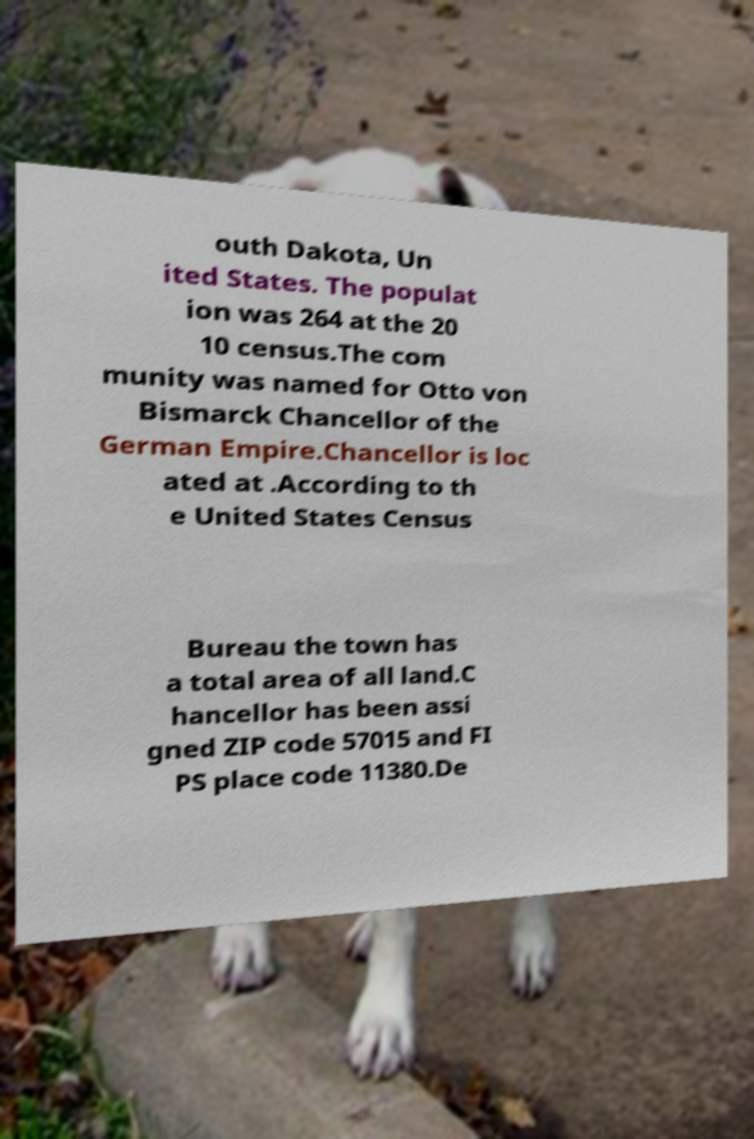Could you extract and type out the text from this image? outh Dakota, Un ited States. The populat ion was 264 at the 20 10 census.The com munity was named for Otto von Bismarck Chancellor of the German Empire.Chancellor is loc ated at .According to th e United States Census Bureau the town has a total area of all land.C hancellor has been assi gned ZIP code 57015 and FI PS place code 11380.De 